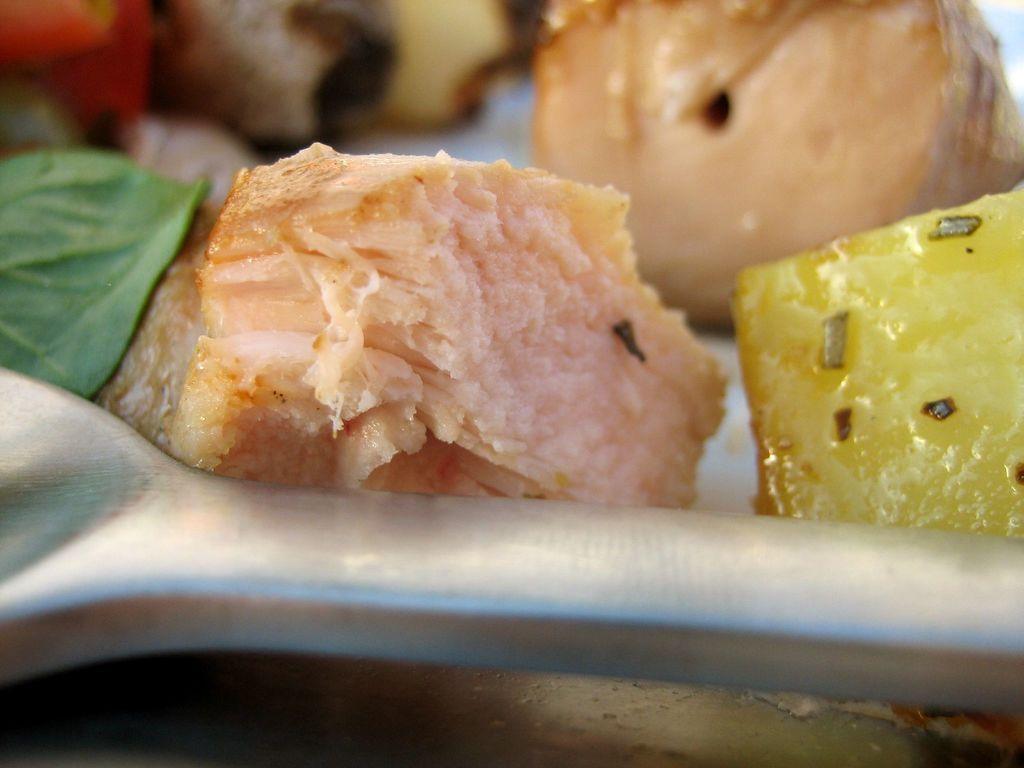Please provide a concise description of this image. In this image, we can see a spoon and some fruits. On the left side of the image, we can also see a leaf. In the background, we can also see some food item. 